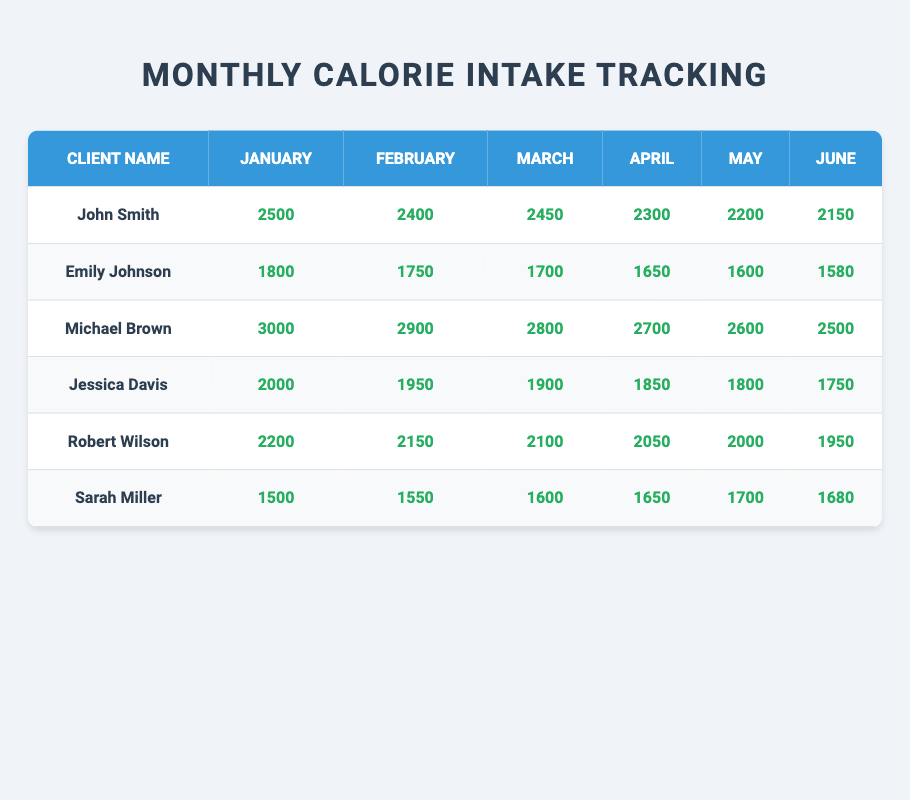What is the highest calorie intake recorded in January? The table shows the calorie intake for January for each client. The values are: John Smith (2500), Emily Johnson (1800), Michael Brown (3000), Jessica Davis (2000), Robert Wilson (2200), and Sarah Miller (1500). The highest value among these is 3000, recorded by Michael Brown.
Answer: 3000 What is the average calorie intake for Robert Wilson over the six months? To find the average, we sum Robert's monthly intakes: 2200 + 2150 + 2100 + 2050 + 2000 + 1950 = 12600. Then, we divide this total by 6 (the number of months), so 12600 / 6 = 2100.
Answer: 2100 Did Emily Johnson's calorie intake increase in March compared to February? In February, Emily's intake was 1750, and in March it was 1700. Since 1700 is less than 1750, her intake did not increase.
Answer: No What was John Smith's percentage decrease in calorie intake from January to June? John’s intake in January was 2500 and in June it was 2150. The decrease is 2500 - 2150 = 350. The percentage decrease is (350 / 2500) * 100 = 14%.
Answer: 14% Who had the lowest calorie intake in June, and what was the value? The clients' calorie intake in June were: John Smith (2150), Emily Johnson (1580), Michael Brown (2500), Jessica Davis (1750), Robert Wilson (1950), and Sarah Miller (1680). The lowest value is 1580, recorded by Emily Johnson.
Answer: Emily Johnson, 1580 What is the overall trend in Jessica Davis's calorie intake over the six months? To analyze the trend, we observe Jessica's intake values: 2000, 1950, 1900, 1850, 1800, 1750. Each subsequent month shows a decrease, indicating a downward trend in her calorie intake.
Answer: Decreasing trend What was the total calorie intake for Michael Brown over the six months? Michael's monthly intakes are 3000 (January), 2900 (February), 2800 (March), 2700 (April), 2600 (May), and 2500 (June). Adding these values: 3000 + 2900 + 2800 + 2700 + 2600 + 2500 = 15,500.
Answer: 15500 How much more did John Smith consume in February compared to Sarah Miller in the same month? John's intake in February was 2400, while Sarah's was 1550. The difference is 2400 - 1550 = 850, meaning John consumed 850 more than Sarah in February.
Answer: 850 In which month did Robert Wilson experience the largest decrease in calorie intake compared to the previous month? Robert’s monthly intakes are: 2200 (January), 2150 (February), 2100 (March), 2050 (April), 2000 (May), and 1950 (June). The largest decrease is from May to June (2000 - 1950 = 50).
Answer: June What was the difference in calorie intake between Michael Brown and Sarah Miller in April? Michael's intake in April was 2700, and Sarah's was 1650. The difference is 2700 - 1650 = 1050.
Answer: 1050 